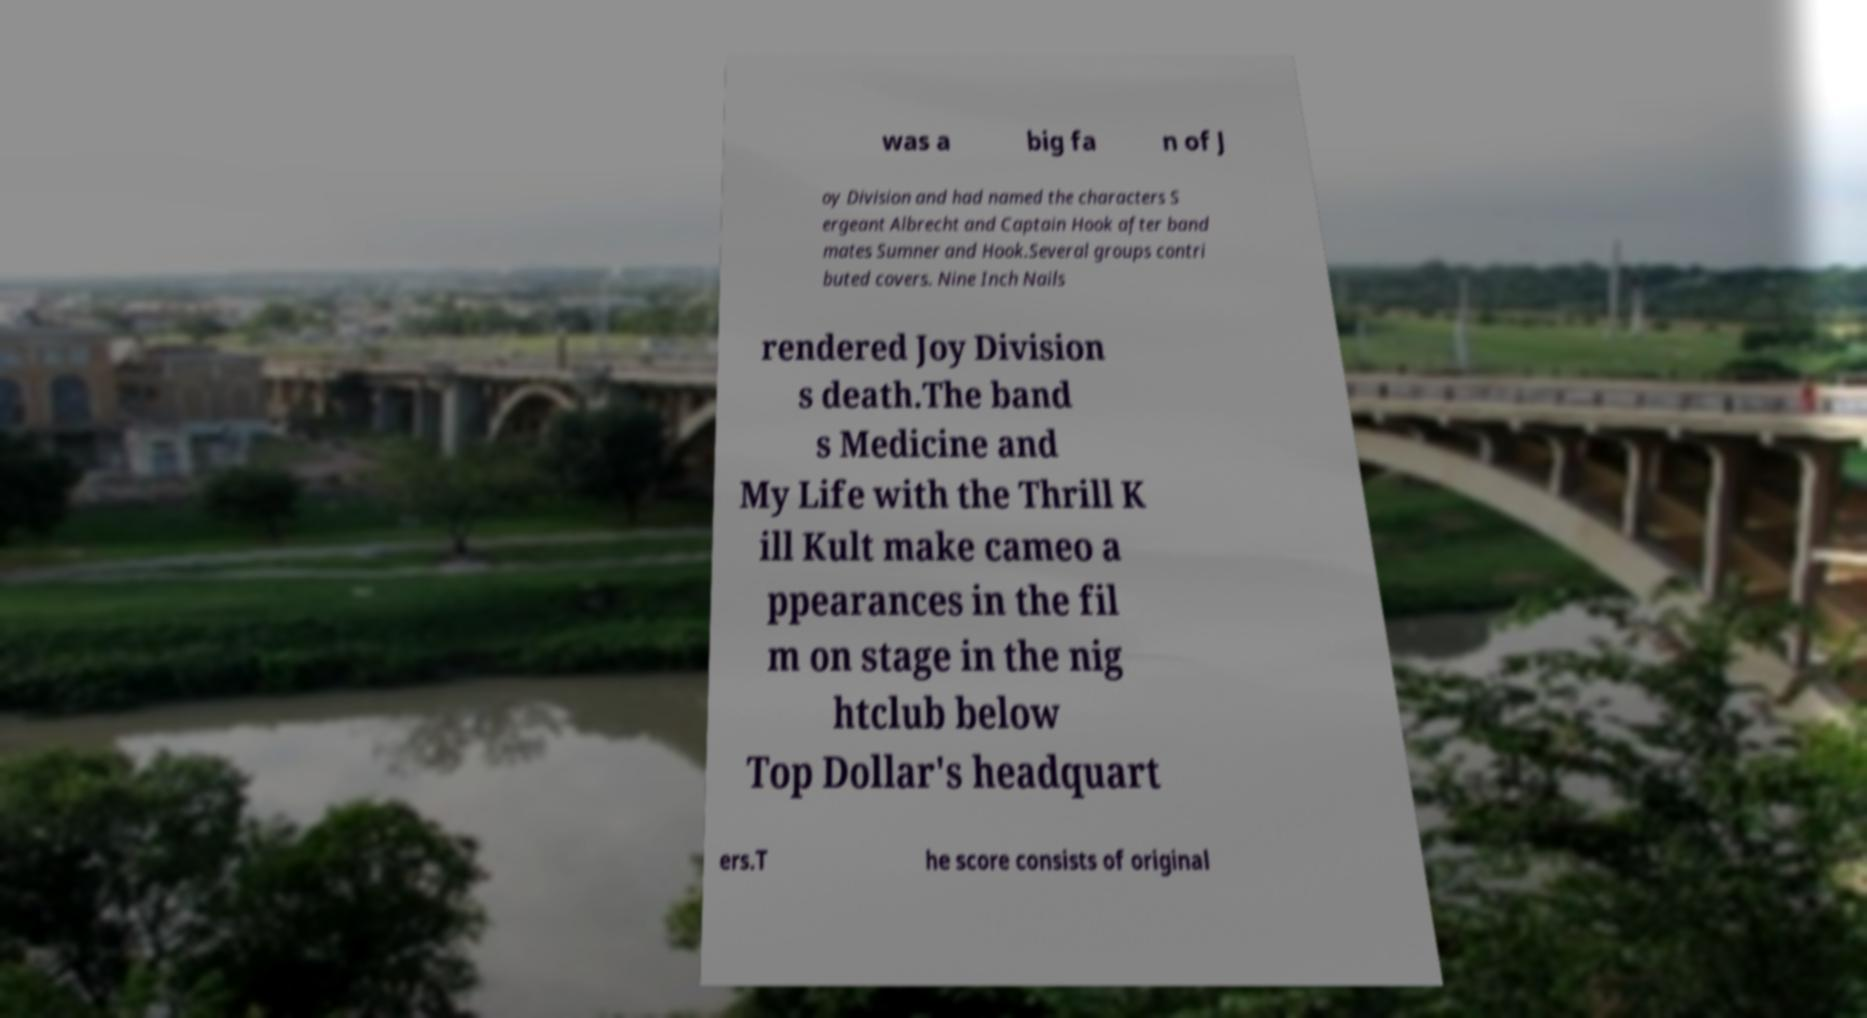There's text embedded in this image that I need extracted. Can you transcribe it verbatim? was a big fa n of J oy Division and had named the characters S ergeant Albrecht and Captain Hook after band mates Sumner and Hook.Several groups contri buted covers. Nine Inch Nails rendered Joy Division s death.The band s Medicine and My Life with the Thrill K ill Kult make cameo a ppearances in the fil m on stage in the nig htclub below Top Dollar's headquart ers.T he score consists of original 